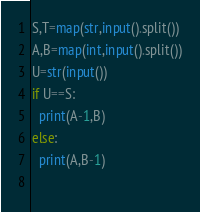Convert code to text. <code><loc_0><loc_0><loc_500><loc_500><_Python_>S,T=map(str,input().split())
A,B=map(int,input().split())
U=str(input())
if U==S:
  print(A-1,B)
else:
  print(A,B-1)
  </code> 